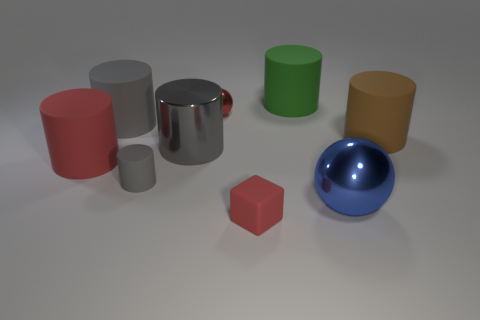Subtract all red blocks. How many gray cylinders are left? 3 Subtract all large green cylinders. How many cylinders are left? 5 Subtract all green cylinders. How many cylinders are left? 5 Subtract all green cylinders. Subtract all blue balls. How many cylinders are left? 5 Subtract all blocks. How many objects are left? 8 Add 7 metallic spheres. How many metallic spheres exist? 9 Subtract 0 yellow blocks. How many objects are left? 9 Subtract all tiny metallic spheres. Subtract all large gray cubes. How many objects are left? 8 Add 2 big gray things. How many big gray things are left? 4 